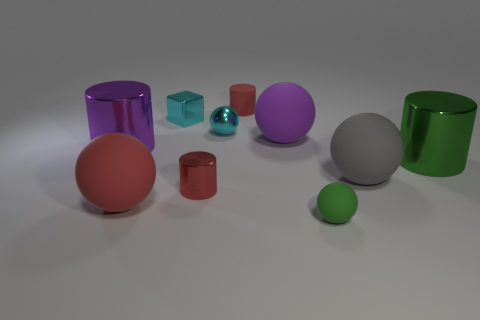Subtract all small shiny spheres. How many spheres are left? 4 Subtract all purple cylinders. How many cylinders are left? 3 Subtract all purple spheres. Subtract all purple cylinders. How many spheres are left? 4 Subtract all blocks. How many objects are left? 9 Add 4 small cyan cylinders. How many small cyan cylinders exist? 4 Subtract 0 cyan cylinders. How many objects are left? 10 Subtract all small brown metal cylinders. Subtract all large purple things. How many objects are left? 8 Add 3 big red spheres. How many big red spheres are left? 4 